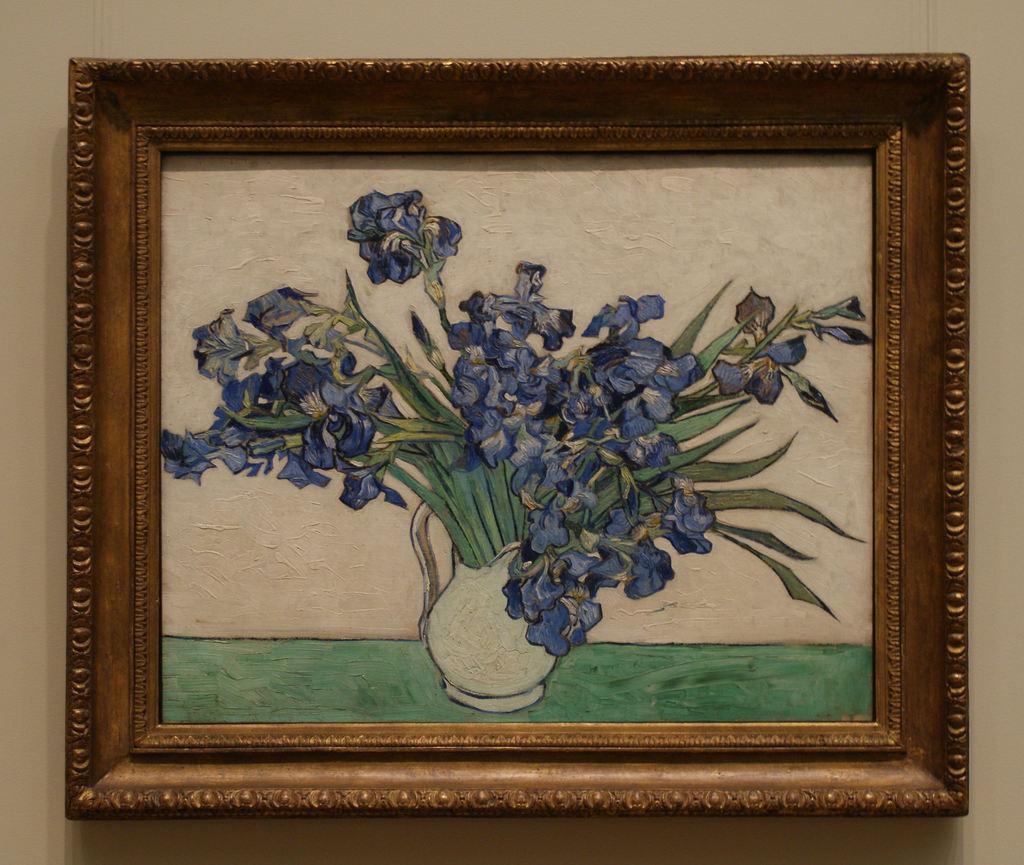How would you summarize this image in a sentence or two? This is a zoomed in picture. In the center we can see a picture frame containing a painting of a flower vase and the flowers which is placed on the top of the green color object. In the background we can see the wall. 